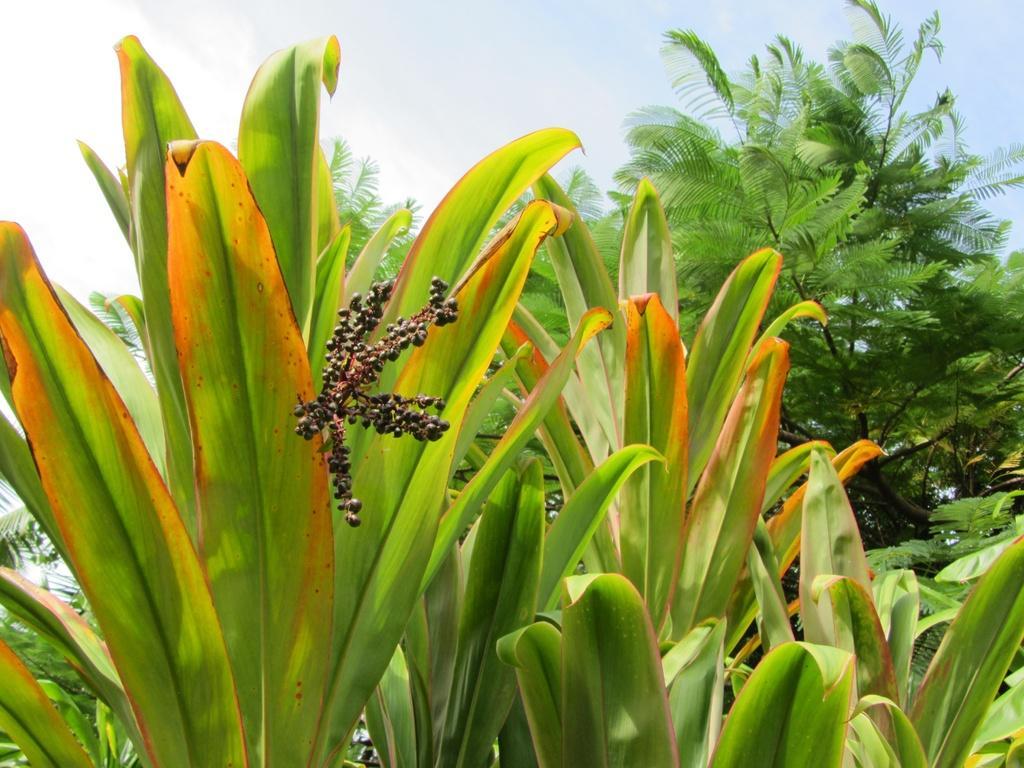Could you give a brief overview of what you see in this image? There are plants having green color leaves. In the background, there are trees and there are clouds in the blue sky. 